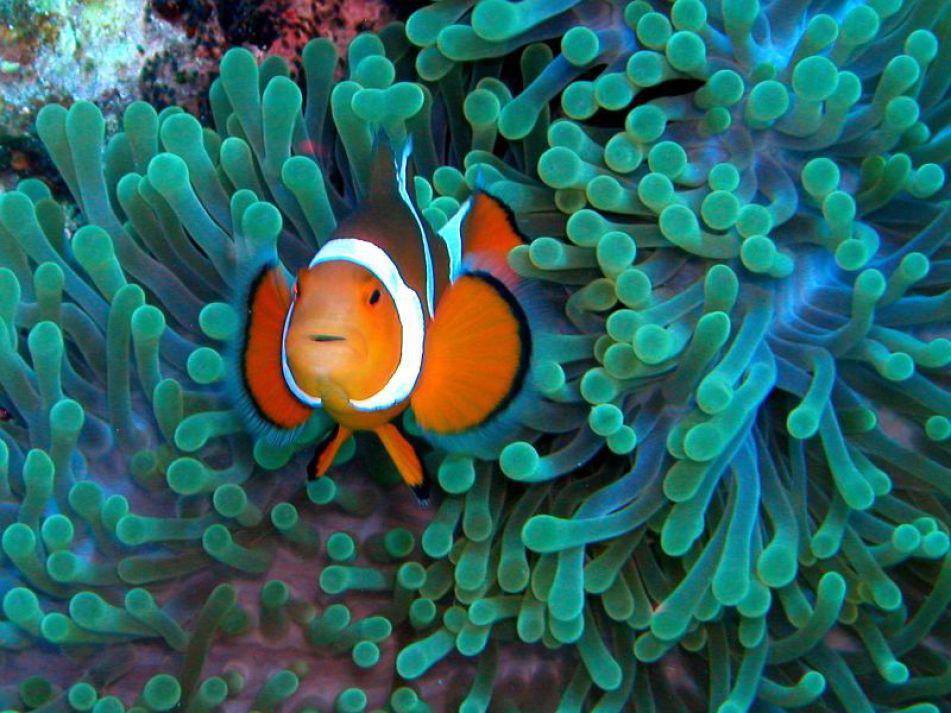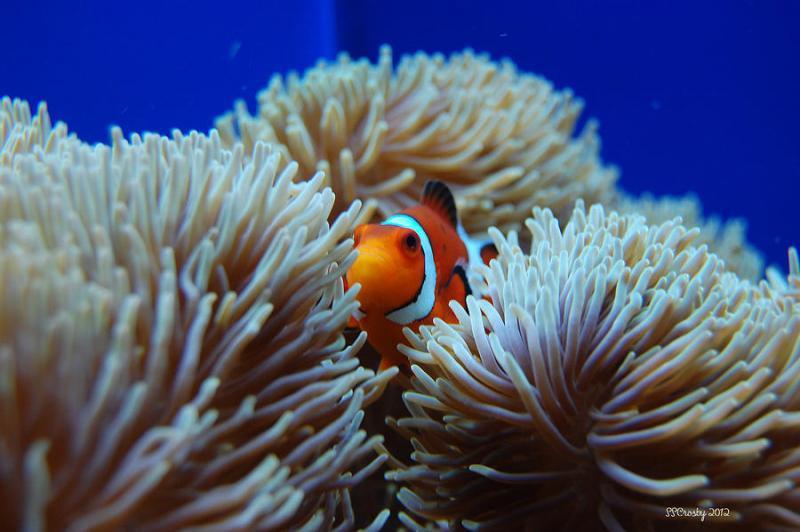The first image is the image on the left, the second image is the image on the right. Analyze the images presented: Is the assertion "In both images the fish are near the sea anemone" valid? Answer yes or no. Yes. 